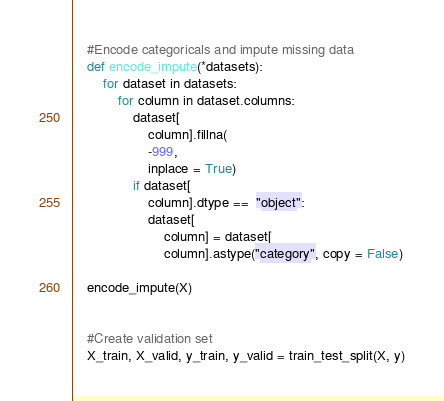<code> <loc_0><loc_0><loc_500><loc_500><_Python_>

    #Encode categoricals and impute missing data
    def encode_impute(*datasets):
        for dataset in datasets:
            for column in dataset.columns:
                dataset[
                    column].fillna(
                    -999,
                    inplace = True)
                if dataset[
                    column].dtype ==  "object":
                    dataset[
                        column] = dataset[
                        column].astype("category", copy = False)

    encode_impute(X)


    #Create validation set
    X_train, X_valid, y_train, y_valid = train_test_split(X, y)

</code> 